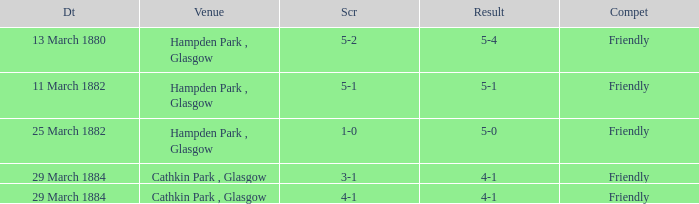Which item resulted in a score of 4-1? 3-1, 4-1. 